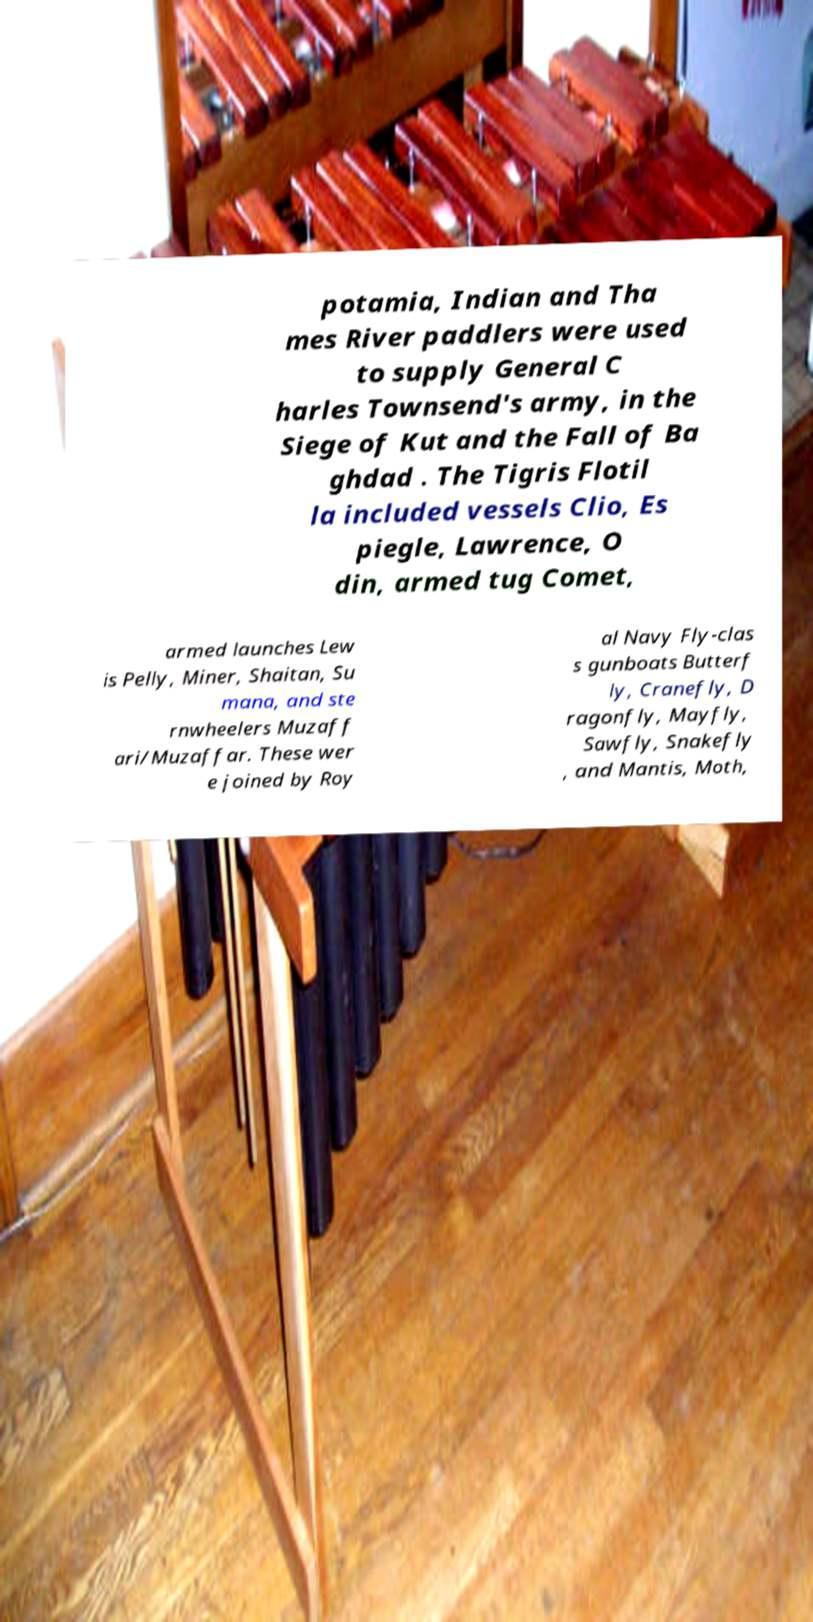There's text embedded in this image that I need extracted. Can you transcribe it verbatim? potamia, Indian and Tha mes River paddlers were used to supply General C harles Townsend's army, in the Siege of Kut and the Fall of Ba ghdad . The Tigris Flotil la included vessels Clio, Es piegle, Lawrence, O din, armed tug Comet, armed launches Lew is Pelly, Miner, Shaitan, Su mana, and ste rnwheelers Muzaff ari/Muzaffar. These wer e joined by Roy al Navy Fly-clas s gunboats Butterf ly, Cranefly, D ragonfly, Mayfly, Sawfly, Snakefly , and Mantis, Moth, 